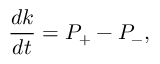Convert formula to latex. <formula><loc_0><loc_0><loc_500><loc_500>\frac { d k } { d t } = P _ { + } - P _ { - } ,</formula> 